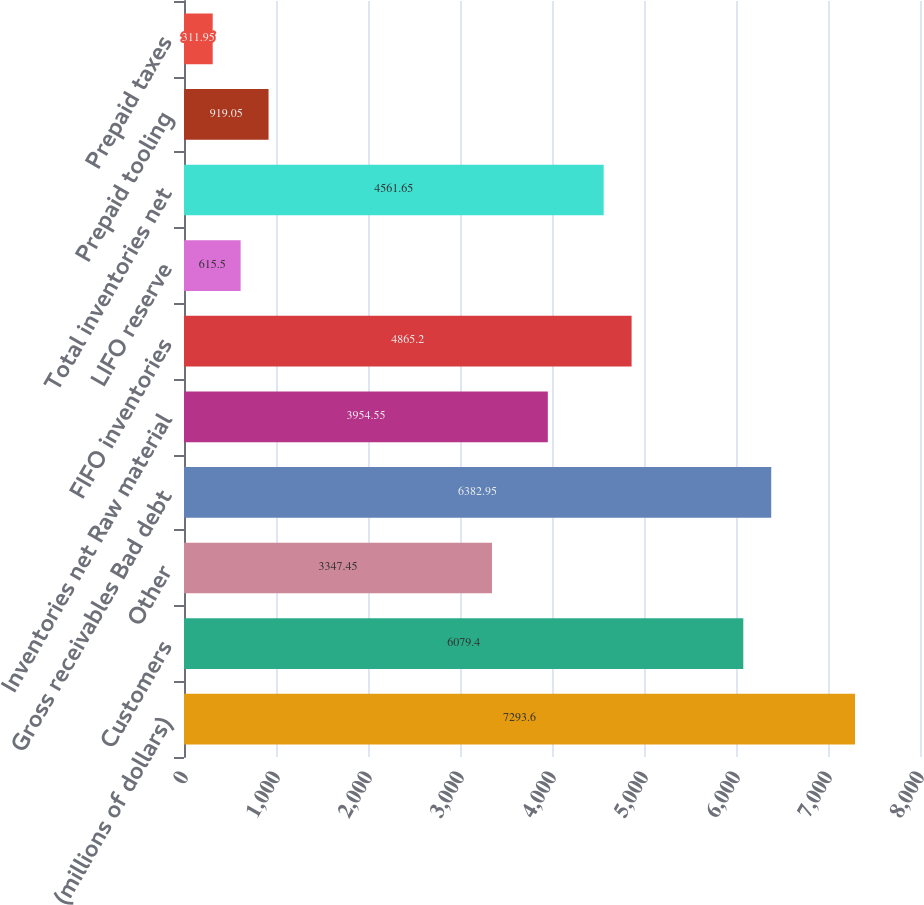<chart> <loc_0><loc_0><loc_500><loc_500><bar_chart><fcel>(millions of dollars)<fcel>Customers<fcel>Other<fcel>Gross receivables Bad debt<fcel>Inventories net Raw material<fcel>FIFO inventories<fcel>LIFO reserve<fcel>Total inventories net<fcel>Prepaid tooling<fcel>Prepaid taxes<nl><fcel>7293.6<fcel>6079.4<fcel>3347.45<fcel>6382.95<fcel>3954.55<fcel>4865.2<fcel>615.5<fcel>4561.65<fcel>919.05<fcel>311.95<nl></chart> 